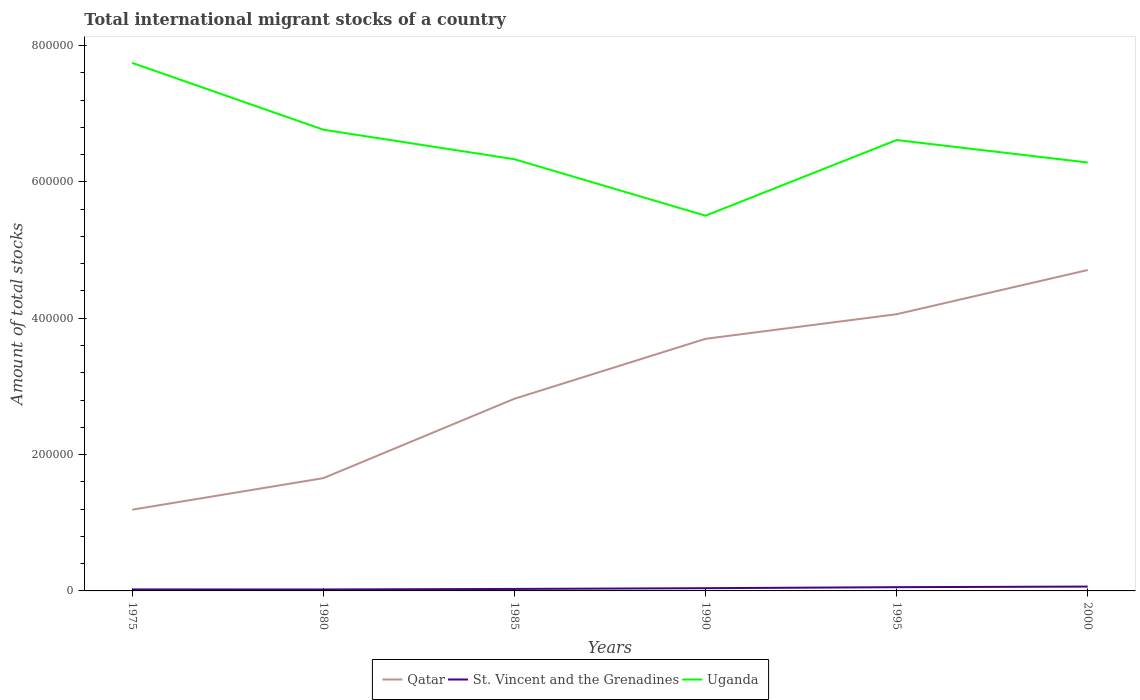How many different coloured lines are there?
Ensure brevity in your answer.  3. Across all years, what is the maximum amount of total stocks in in Uganda?
Offer a terse response. 5.50e+05. In which year was the amount of total stocks in in Uganda maximum?
Make the answer very short. 1990. What is the total amount of total stocks in in Qatar in the graph?
Offer a terse response. -6.48e+04. What is the difference between the highest and the second highest amount of total stocks in in Qatar?
Ensure brevity in your answer.  3.52e+05. What is the difference between two consecutive major ticks on the Y-axis?
Ensure brevity in your answer.  2.00e+05. Does the graph contain any zero values?
Give a very brief answer. No. How are the legend labels stacked?
Offer a terse response. Horizontal. What is the title of the graph?
Offer a very short reply. Total international migrant stocks of a country. Does "Peru" appear as one of the legend labels in the graph?
Your response must be concise. No. What is the label or title of the Y-axis?
Offer a terse response. Amount of total stocks. What is the Amount of total stocks of Qatar in 1975?
Offer a terse response. 1.19e+05. What is the Amount of total stocks in St. Vincent and the Grenadines in 1975?
Make the answer very short. 2199. What is the Amount of total stocks of Uganda in 1975?
Offer a very short reply. 7.75e+05. What is the Amount of total stocks in Qatar in 1980?
Your answer should be very brief. 1.65e+05. What is the Amount of total stocks in St. Vincent and the Grenadines in 1980?
Make the answer very short. 2129. What is the Amount of total stocks in Uganda in 1980?
Offer a very short reply. 6.77e+05. What is the Amount of total stocks in Qatar in 1985?
Ensure brevity in your answer.  2.82e+05. What is the Amount of total stocks of St. Vincent and the Grenadines in 1985?
Make the answer very short. 2920. What is the Amount of total stocks of Uganda in 1985?
Your answer should be very brief. 6.33e+05. What is the Amount of total stocks of Qatar in 1990?
Give a very brief answer. 3.70e+05. What is the Amount of total stocks of St. Vincent and the Grenadines in 1990?
Your response must be concise. 4004. What is the Amount of total stocks in Uganda in 1990?
Provide a short and direct response. 5.50e+05. What is the Amount of total stocks of Qatar in 1995?
Provide a short and direct response. 4.06e+05. What is the Amount of total stocks of St. Vincent and the Grenadines in 1995?
Your answer should be compact. 5492. What is the Amount of total stocks in Uganda in 1995?
Give a very brief answer. 6.61e+05. What is the Amount of total stocks in Qatar in 2000?
Ensure brevity in your answer.  4.71e+05. What is the Amount of total stocks in St. Vincent and the Grenadines in 2000?
Make the answer very short. 6380. What is the Amount of total stocks of Uganda in 2000?
Your answer should be compact. 6.28e+05. Across all years, what is the maximum Amount of total stocks of Qatar?
Give a very brief answer. 4.71e+05. Across all years, what is the maximum Amount of total stocks in St. Vincent and the Grenadines?
Keep it short and to the point. 6380. Across all years, what is the maximum Amount of total stocks of Uganda?
Your answer should be compact. 7.75e+05. Across all years, what is the minimum Amount of total stocks in Qatar?
Offer a very short reply. 1.19e+05. Across all years, what is the minimum Amount of total stocks in St. Vincent and the Grenadines?
Your answer should be very brief. 2129. Across all years, what is the minimum Amount of total stocks in Uganda?
Provide a succinct answer. 5.50e+05. What is the total Amount of total stocks of Qatar in the graph?
Provide a short and direct response. 1.81e+06. What is the total Amount of total stocks in St. Vincent and the Grenadines in the graph?
Ensure brevity in your answer.  2.31e+04. What is the total Amount of total stocks in Uganda in the graph?
Offer a very short reply. 3.92e+06. What is the difference between the Amount of total stocks of Qatar in 1975 and that in 1980?
Your answer should be very brief. -4.62e+04. What is the difference between the Amount of total stocks in Uganda in 1975 and that in 1980?
Offer a very short reply. 9.80e+04. What is the difference between the Amount of total stocks of Qatar in 1975 and that in 1985?
Your answer should be very brief. -1.63e+05. What is the difference between the Amount of total stocks of St. Vincent and the Grenadines in 1975 and that in 1985?
Offer a terse response. -721. What is the difference between the Amount of total stocks in Uganda in 1975 and that in 1985?
Provide a succinct answer. 1.41e+05. What is the difference between the Amount of total stocks of Qatar in 1975 and that in 1990?
Give a very brief answer. -2.51e+05. What is the difference between the Amount of total stocks of St. Vincent and the Grenadines in 1975 and that in 1990?
Your answer should be compact. -1805. What is the difference between the Amount of total stocks of Uganda in 1975 and that in 1990?
Offer a very short reply. 2.24e+05. What is the difference between the Amount of total stocks in Qatar in 1975 and that in 1995?
Your response must be concise. -2.87e+05. What is the difference between the Amount of total stocks of St. Vincent and the Grenadines in 1975 and that in 1995?
Ensure brevity in your answer.  -3293. What is the difference between the Amount of total stocks of Uganda in 1975 and that in 1995?
Give a very brief answer. 1.13e+05. What is the difference between the Amount of total stocks in Qatar in 1975 and that in 2000?
Provide a short and direct response. -3.52e+05. What is the difference between the Amount of total stocks in St. Vincent and the Grenadines in 1975 and that in 2000?
Provide a succinct answer. -4181. What is the difference between the Amount of total stocks in Uganda in 1975 and that in 2000?
Ensure brevity in your answer.  1.46e+05. What is the difference between the Amount of total stocks of Qatar in 1980 and that in 1985?
Your answer should be compact. -1.16e+05. What is the difference between the Amount of total stocks in St. Vincent and the Grenadines in 1980 and that in 1985?
Ensure brevity in your answer.  -791. What is the difference between the Amount of total stocks in Uganda in 1980 and that in 1985?
Ensure brevity in your answer.  4.33e+04. What is the difference between the Amount of total stocks in Qatar in 1980 and that in 1990?
Keep it short and to the point. -2.04e+05. What is the difference between the Amount of total stocks of St. Vincent and the Grenadines in 1980 and that in 1990?
Make the answer very short. -1875. What is the difference between the Amount of total stocks in Uganda in 1980 and that in 1990?
Your answer should be very brief. 1.26e+05. What is the difference between the Amount of total stocks in Qatar in 1980 and that in 1995?
Offer a very short reply. -2.40e+05. What is the difference between the Amount of total stocks in St. Vincent and the Grenadines in 1980 and that in 1995?
Your response must be concise. -3363. What is the difference between the Amount of total stocks in Uganda in 1980 and that in 1995?
Ensure brevity in your answer.  1.52e+04. What is the difference between the Amount of total stocks of Qatar in 1980 and that in 2000?
Your answer should be very brief. -3.05e+05. What is the difference between the Amount of total stocks of St. Vincent and the Grenadines in 1980 and that in 2000?
Give a very brief answer. -4251. What is the difference between the Amount of total stocks of Uganda in 1980 and that in 2000?
Offer a terse response. 4.82e+04. What is the difference between the Amount of total stocks of Qatar in 1985 and that in 1990?
Offer a very short reply. -8.79e+04. What is the difference between the Amount of total stocks in St. Vincent and the Grenadines in 1985 and that in 1990?
Give a very brief answer. -1084. What is the difference between the Amount of total stocks in Uganda in 1985 and that in 1990?
Provide a succinct answer. 8.29e+04. What is the difference between the Amount of total stocks of Qatar in 1985 and that in 1995?
Your response must be concise. -1.24e+05. What is the difference between the Amount of total stocks in St. Vincent and the Grenadines in 1985 and that in 1995?
Your answer should be compact. -2572. What is the difference between the Amount of total stocks of Uganda in 1985 and that in 1995?
Your answer should be very brief. -2.82e+04. What is the difference between the Amount of total stocks in Qatar in 1985 and that in 2000?
Provide a short and direct response. -1.89e+05. What is the difference between the Amount of total stocks of St. Vincent and the Grenadines in 1985 and that in 2000?
Make the answer very short. -3460. What is the difference between the Amount of total stocks of Uganda in 1985 and that in 2000?
Provide a short and direct response. 4857. What is the difference between the Amount of total stocks of Qatar in 1990 and that in 1995?
Keep it short and to the point. -3.61e+04. What is the difference between the Amount of total stocks of St. Vincent and the Grenadines in 1990 and that in 1995?
Offer a terse response. -1488. What is the difference between the Amount of total stocks in Uganda in 1990 and that in 1995?
Your response must be concise. -1.11e+05. What is the difference between the Amount of total stocks of Qatar in 1990 and that in 2000?
Make the answer very short. -1.01e+05. What is the difference between the Amount of total stocks of St. Vincent and the Grenadines in 1990 and that in 2000?
Provide a short and direct response. -2376. What is the difference between the Amount of total stocks in Uganda in 1990 and that in 2000?
Provide a succinct answer. -7.80e+04. What is the difference between the Amount of total stocks of Qatar in 1995 and that in 2000?
Your answer should be very brief. -6.48e+04. What is the difference between the Amount of total stocks in St. Vincent and the Grenadines in 1995 and that in 2000?
Your answer should be very brief. -888. What is the difference between the Amount of total stocks of Uganda in 1995 and that in 2000?
Offer a very short reply. 3.30e+04. What is the difference between the Amount of total stocks in Qatar in 1975 and the Amount of total stocks in St. Vincent and the Grenadines in 1980?
Your answer should be compact. 1.17e+05. What is the difference between the Amount of total stocks of Qatar in 1975 and the Amount of total stocks of Uganda in 1980?
Ensure brevity in your answer.  -5.57e+05. What is the difference between the Amount of total stocks in St. Vincent and the Grenadines in 1975 and the Amount of total stocks in Uganda in 1980?
Offer a terse response. -6.74e+05. What is the difference between the Amount of total stocks in Qatar in 1975 and the Amount of total stocks in St. Vincent and the Grenadines in 1985?
Give a very brief answer. 1.16e+05. What is the difference between the Amount of total stocks in Qatar in 1975 and the Amount of total stocks in Uganda in 1985?
Your answer should be very brief. -5.14e+05. What is the difference between the Amount of total stocks of St. Vincent and the Grenadines in 1975 and the Amount of total stocks of Uganda in 1985?
Keep it short and to the point. -6.31e+05. What is the difference between the Amount of total stocks of Qatar in 1975 and the Amount of total stocks of St. Vincent and the Grenadines in 1990?
Provide a short and direct response. 1.15e+05. What is the difference between the Amount of total stocks of Qatar in 1975 and the Amount of total stocks of Uganda in 1990?
Offer a terse response. -4.31e+05. What is the difference between the Amount of total stocks in St. Vincent and the Grenadines in 1975 and the Amount of total stocks in Uganda in 1990?
Make the answer very short. -5.48e+05. What is the difference between the Amount of total stocks of Qatar in 1975 and the Amount of total stocks of St. Vincent and the Grenadines in 1995?
Offer a terse response. 1.14e+05. What is the difference between the Amount of total stocks in Qatar in 1975 and the Amount of total stocks in Uganda in 1995?
Keep it short and to the point. -5.42e+05. What is the difference between the Amount of total stocks of St. Vincent and the Grenadines in 1975 and the Amount of total stocks of Uganda in 1995?
Provide a succinct answer. -6.59e+05. What is the difference between the Amount of total stocks of Qatar in 1975 and the Amount of total stocks of St. Vincent and the Grenadines in 2000?
Your response must be concise. 1.13e+05. What is the difference between the Amount of total stocks in Qatar in 1975 and the Amount of total stocks in Uganda in 2000?
Your response must be concise. -5.09e+05. What is the difference between the Amount of total stocks of St. Vincent and the Grenadines in 1975 and the Amount of total stocks of Uganda in 2000?
Ensure brevity in your answer.  -6.26e+05. What is the difference between the Amount of total stocks in Qatar in 1980 and the Amount of total stocks in St. Vincent and the Grenadines in 1985?
Ensure brevity in your answer.  1.63e+05. What is the difference between the Amount of total stocks in Qatar in 1980 and the Amount of total stocks in Uganda in 1985?
Give a very brief answer. -4.68e+05. What is the difference between the Amount of total stocks in St. Vincent and the Grenadines in 1980 and the Amount of total stocks in Uganda in 1985?
Offer a very short reply. -6.31e+05. What is the difference between the Amount of total stocks of Qatar in 1980 and the Amount of total stocks of St. Vincent and the Grenadines in 1990?
Make the answer very short. 1.61e+05. What is the difference between the Amount of total stocks in Qatar in 1980 and the Amount of total stocks in Uganda in 1990?
Offer a terse response. -3.85e+05. What is the difference between the Amount of total stocks in St. Vincent and the Grenadines in 1980 and the Amount of total stocks in Uganda in 1990?
Offer a very short reply. -5.48e+05. What is the difference between the Amount of total stocks of Qatar in 1980 and the Amount of total stocks of St. Vincent and the Grenadines in 1995?
Your answer should be very brief. 1.60e+05. What is the difference between the Amount of total stocks in Qatar in 1980 and the Amount of total stocks in Uganda in 1995?
Keep it short and to the point. -4.96e+05. What is the difference between the Amount of total stocks of St. Vincent and the Grenadines in 1980 and the Amount of total stocks of Uganda in 1995?
Your answer should be very brief. -6.59e+05. What is the difference between the Amount of total stocks of Qatar in 1980 and the Amount of total stocks of St. Vincent and the Grenadines in 2000?
Keep it short and to the point. 1.59e+05. What is the difference between the Amount of total stocks of Qatar in 1980 and the Amount of total stocks of Uganda in 2000?
Give a very brief answer. -4.63e+05. What is the difference between the Amount of total stocks of St. Vincent and the Grenadines in 1980 and the Amount of total stocks of Uganda in 2000?
Make the answer very short. -6.26e+05. What is the difference between the Amount of total stocks in Qatar in 1985 and the Amount of total stocks in St. Vincent and the Grenadines in 1990?
Provide a short and direct response. 2.78e+05. What is the difference between the Amount of total stocks of Qatar in 1985 and the Amount of total stocks of Uganda in 1990?
Make the answer very short. -2.69e+05. What is the difference between the Amount of total stocks of St. Vincent and the Grenadines in 1985 and the Amount of total stocks of Uganda in 1990?
Make the answer very short. -5.48e+05. What is the difference between the Amount of total stocks of Qatar in 1985 and the Amount of total stocks of St. Vincent and the Grenadines in 1995?
Your response must be concise. 2.76e+05. What is the difference between the Amount of total stocks of Qatar in 1985 and the Amount of total stocks of Uganda in 1995?
Provide a succinct answer. -3.80e+05. What is the difference between the Amount of total stocks of St. Vincent and the Grenadines in 1985 and the Amount of total stocks of Uganda in 1995?
Your response must be concise. -6.59e+05. What is the difference between the Amount of total stocks in Qatar in 1985 and the Amount of total stocks in St. Vincent and the Grenadines in 2000?
Give a very brief answer. 2.76e+05. What is the difference between the Amount of total stocks in Qatar in 1985 and the Amount of total stocks in Uganda in 2000?
Give a very brief answer. -3.47e+05. What is the difference between the Amount of total stocks of St. Vincent and the Grenadines in 1985 and the Amount of total stocks of Uganda in 2000?
Give a very brief answer. -6.26e+05. What is the difference between the Amount of total stocks in Qatar in 1990 and the Amount of total stocks in St. Vincent and the Grenadines in 1995?
Keep it short and to the point. 3.64e+05. What is the difference between the Amount of total stocks in Qatar in 1990 and the Amount of total stocks in Uganda in 1995?
Offer a terse response. -2.92e+05. What is the difference between the Amount of total stocks of St. Vincent and the Grenadines in 1990 and the Amount of total stocks of Uganda in 1995?
Offer a terse response. -6.57e+05. What is the difference between the Amount of total stocks in Qatar in 1990 and the Amount of total stocks in St. Vincent and the Grenadines in 2000?
Provide a succinct answer. 3.63e+05. What is the difference between the Amount of total stocks in Qatar in 1990 and the Amount of total stocks in Uganda in 2000?
Provide a succinct answer. -2.59e+05. What is the difference between the Amount of total stocks of St. Vincent and the Grenadines in 1990 and the Amount of total stocks of Uganda in 2000?
Ensure brevity in your answer.  -6.24e+05. What is the difference between the Amount of total stocks of Qatar in 1995 and the Amount of total stocks of St. Vincent and the Grenadines in 2000?
Make the answer very short. 4.00e+05. What is the difference between the Amount of total stocks in Qatar in 1995 and the Amount of total stocks in Uganda in 2000?
Offer a very short reply. -2.23e+05. What is the difference between the Amount of total stocks of St. Vincent and the Grenadines in 1995 and the Amount of total stocks of Uganda in 2000?
Ensure brevity in your answer.  -6.23e+05. What is the average Amount of total stocks in Qatar per year?
Make the answer very short. 3.02e+05. What is the average Amount of total stocks in St. Vincent and the Grenadines per year?
Offer a terse response. 3854. What is the average Amount of total stocks of Uganda per year?
Your answer should be compact. 6.54e+05. In the year 1975, what is the difference between the Amount of total stocks of Qatar and Amount of total stocks of St. Vincent and the Grenadines?
Your answer should be very brief. 1.17e+05. In the year 1975, what is the difference between the Amount of total stocks of Qatar and Amount of total stocks of Uganda?
Your answer should be very brief. -6.55e+05. In the year 1975, what is the difference between the Amount of total stocks in St. Vincent and the Grenadines and Amount of total stocks in Uganda?
Ensure brevity in your answer.  -7.72e+05. In the year 1980, what is the difference between the Amount of total stocks in Qatar and Amount of total stocks in St. Vincent and the Grenadines?
Your answer should be very brief. 1.63e+05. In the year 1980, what is the difference between the Amount of total stocks in Qatar and Amount of total stocks in Uganda?
Your response must be concise. -5.11e+05. In the year 1980, what is the difference between the Amount of total stocks in St. Vincent and the Grenadines and Amount of total stocks in Uganda?
Make the answer very short. -6.74e+05. In the year 1985, what is the difference between the Amount of total stocks of Qatar and Amount of total stocks of St. Vincent and the Grenadines?
Give a very brief answer. 2.79e+05. In the year 1985, what is the difference between the Amount of total stocks of Qatar and Amount of total stocks of Uganda?
Give a very brief answer. -3.51e+05. In the year 1985, what is the difference between the Amount of total stocks of St. Vincent and the Grenadines and Amount of total stocks of Uganda?
Give a very brief answer. -6.30e+05. In the year 1990, what is the difference between the Amount of total stocks of Qatar and Amount of total stocks of St. Vincent and the Grenadines?
Offer a very short reply. 3.66e+05. In the year 1990, what is the difference between the Amount of total stocks of Qatar and Amount of total stocks of Uganda?
Keep it short and to the point. -1.81e+05. In the year 1990, what is the difference between the Amount of total stocks in St. Vincent and the Grenadines and Amount of total stocks in Uganda?
Provide a short and direct response. -5.46e+05. In the year 1995, what is the difference between the Amount of total stocks in Qatar and Amount of total stocks in St. Vincent and the Grenadines?
Offer a very short reply. 4.00e+05. In the year 1995, what is the difference between the Amount of total stocks of Qatar and Amount of total stocks of Uganda?
Ensure brevity in your answer.  -2.56e+05. In the year 1995, what is the difference between the Amount of total stocks of St. Vincent and the Grenadines and Amount of total stocks of Uganda?
Your answer should be compact. -6.56e+05. In the year 2000, what is the difference between the Amount of total stocks of Qatar and Amount of total stocks of St. Vincent and the Grenadines?
Ensure brevity in your answer.  4.64e+05. In the year 2000, what is the difference between the Amount of total stocks of Qatar and Amount of total stocks of Uganda?
Your answer should be compact. -1.58e+05. In the year 2000, what is the difference between the Amount of total stocks of St. Vincent and the Grenadines and Amount of total stocks of Uganda?
Your answer should be compact. -6.22e+05. What is the ratio of the Amount of total stocks of Qatar in 1975 to that in 1980?
Your answer should be compact. 0.72. What is the ratio of the Amount of total stocks of St. Vincent and the Grenadines in 1975 to that in 1980?
Make the answer very short. 1.03. What is the ratio of the Amount of total stocks in Uganda in 1975 to that in 1980?
Give a very brief answer. 1.14. What is the ratio of the Amount of total stocks in Qatar in 1975 to that in 1985?
Provide a short and direct response. 0.42. What is the ratio of the Amount of total stocks in St. Vincent and the Grenadines in 1975 to that in 1985?
Offer a terse response. 0.75. What is the ratio of the Amount of total stocks of Uganda in 1975 to that in 1985?
Make the answer very short. 1.22. What is the ratio of the Amount of total stocks of Qatar in 1975 to that in 1990?
Give a very brief answer. 0.32. What is the ratio of the Amount of total stocks in St. Vincent and the Grenadines in 1975 to that in 1990?
Keep it short and to the point. 0.55. What is the ratio of the Amount of total stocks of Uganda in 1975 to that in 1990?
Keep it short and to the point. 1.41. What is the ratio of the Amount of total stocks in Qatar in 1975 to that in 1995?
Offer a very short reply. 0.29. What is the ratio of the Amount of total stocks in St. Vincent and the Grenadines in 1975 to that in 1995?
Your answer should be compact. 0.4. What is the ratio of the Amount of total stocks of Uganda in 1975 to that in 1995?
Offer a very short reply. 1.17. What is the ratio of the Amount of total stocks in Qatar in 1975 to that in 2000?
Offer a very short reply. 0.25. What is the ratio of the Amount of total stocks of St. Vincent and the Grenadines in 1975 to that in 2000?
Provide a short and direct response. 0.34. What is the ratio of the Amount of total stocks in Uganda in 1975 to that in 2000?
Ensure brevity in your answer.  1.23. What is the ratio of the Amount of total stocks of Qatar in 1980 to that in 1985?
Your answer should be very brief. 0.59. What is the ratio of the Amount of total stocks in St. Vincent and the Grenadines in 1980 to that in 1985?
Give a very brief answer. 0.73. What is the ratio of the Amount of total stocks of Uganda in 1980 to that in 1985?
Keep it short and to the point. 1.07. What is the ratio of the Amount of total stocks in Qatar in 1980 to that in 1990?
Your response must be concise. 0.45. What is the ratio of the Amount of total stocks in St. Vincent and the Grenadines in 1980 to that in 1990?
Ensure brevity in your answer.  0.53. What is the ratio of the Amount of total stocks in Uganda in 1980 to that in 1990?
Your answer should be very brief. 1.23. What is the ratio of the Amount of total stocks of Qatar in 1980 to that in 1995?
Keep it short and to the point. 0.41. What is the ratio of the Amount of total stocks of St. Vincent and the Grenadines in 1980 to that in 1995?
Ensure brevity in your answer.  0.39. What is the ratio of the Amount of total stocks of Uganda in 1980 to that in 1995?
Make the answer very short. 1.02. What is the ratio of the Amount of total stocks of Qatar in 1980 to that in 2000?
Provide a short and direct response. 0.35. What is the ratio of the Amount of total stocks of St. Vincent and the Grenadines in 1980 to that in 2000?
Ensure brevity in your answer.  0.33. What is the ratio of the Amount of total stocks in Uganda in 1980 to that in 2000?
Provide a succinct answer. 1.08. What is the ratio of the Amount of total stocks of Qatar in 1985 to that in 1990?
Offer a terse response. 0.76. What is the ratio of the Amount of total stocks in St. Vincent and the Grenadines in 1985 to that in 1990?
Offer a very short reply. 0.73. What is the ratio of the Amount of total stocks of Uganda in 1985 to that in 1990?
Ensure brevity in your answer.  1.15. What is the ratio of the Amount of total stocks in Qatar in 1985 to that in 1995?
Offer a very short reply. 0.69. What is the ratio of the Amount of total stocks in St. Vincent and the Grenadines in 1985 to that in 1995?
Make the answer very short. 0.53. What is the ratio of the Amount of total stocks of Uganda in 1985 to that in 1995?
Provide a succinct answer. 0.96. What is the ratio of the Amount of total stocks of Qatar in 1985 to that in 2000?
Offer a terse response. 0.6. What is the ratio of the Amount of total stocks in St. Vincent and the Grenadines in 1985 to that in 2000?
Make the answer very short. 0.46. What is the ratio of the Amount of total stocks in Uganda in 1985 to that in 2000?
Ensure brevity in your answer.  1.01. What is the ratio of the Amount of total stocks of Qatar in 1990 to that in 1995?
Your answer should be very brief. 0.91. What is the ratio of the Amount of total stocks in St. Vincent and the Grenadines in 1990 to that in 1995?
Keep it short and to the point. 0.73. What is the ratio of the Amount of total stocks of Uganda in 1990 to that in 1995?
Your response must be concise. 0.83. What is the ratio of the Amount of total stocks of Qatar in 1990 to that in 2000?
Ensure brevity in your answer.  0.79. What is the ratio of the Amount of total stocks of St. Vincent and the Grenadines in 1990 to that in 2000?
Give a very brief answer. 0.63. What is the ratio of the Amount of total stocks of Uganda in 1990 to that in 2000?
Provide a succinct answer. 0.88. What is the ratio of the Amount of total stocks of Qatar in 1995 to that in 2000?
Give a very brief answer. 0.86. What is the ratio of the Amount of total stocks in St. Vincent and the Grenadines in 1995 to that in 2000?
Keep it short and to the point. 0.86. What is the ratio of the Amount of total stocks in Uganda in 1995 to that in 2000?
Offer a terse response. 1.05. What is the difference between the highest and the second highest Amount of total stocks in Qatar?
Offer a terse response. 6.48e+04. What is the difference between the highest and the second highest Amount of total stocks in St. Vincent and the Grenadines?
Provide a short and direct response. 888. What is the difference between the highest and the second highest Amount of total stocks of Uganda?
Keep it short and to the point. 9.80e+04. What is the difference between the highest and the lowest Amount of total stocks of Qatar?
Offer a very short reply. 3.52e+05. What is the difference between the highest and the lowest Amount of total stocks of St. Vincent and the Grenadines?
Provide a short and direct response. 4251. What is the difference between the highest and the lowest Amount of total stocks of Uganda?
Offer a very short reply. 2.24e+05. 